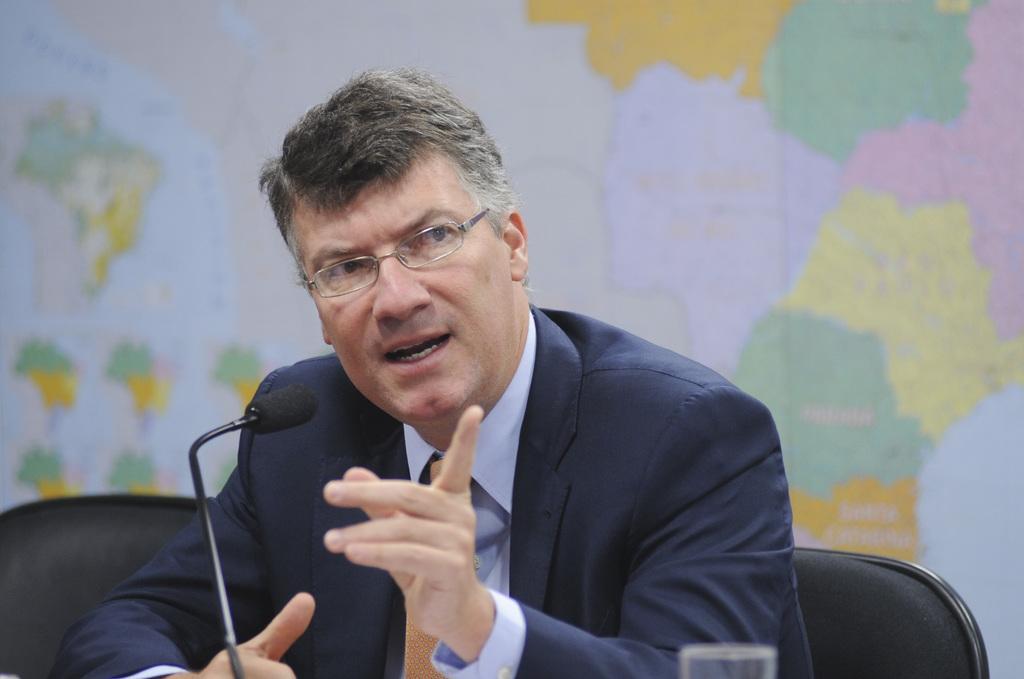How would you summarize this image in a sentence or two? In the middle of this image, there is a person in a suit, sitting on a chair, speaking and showing something with a hand in front of a microphone and a glass. On the left side, there is another chair. In the background, there is a map. 